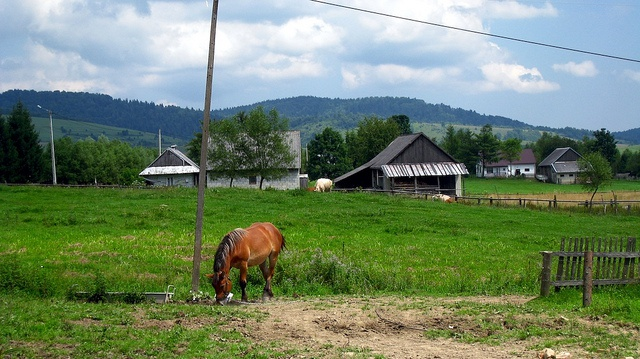Describe the objects in this image and their specific colors. I can see horse in lavender, black, brown, maroon, and olive tones, cow in lightblue, ivory, and tan tones, and cow in lightblue, darkgreen, beige, and gray tones in this image. 